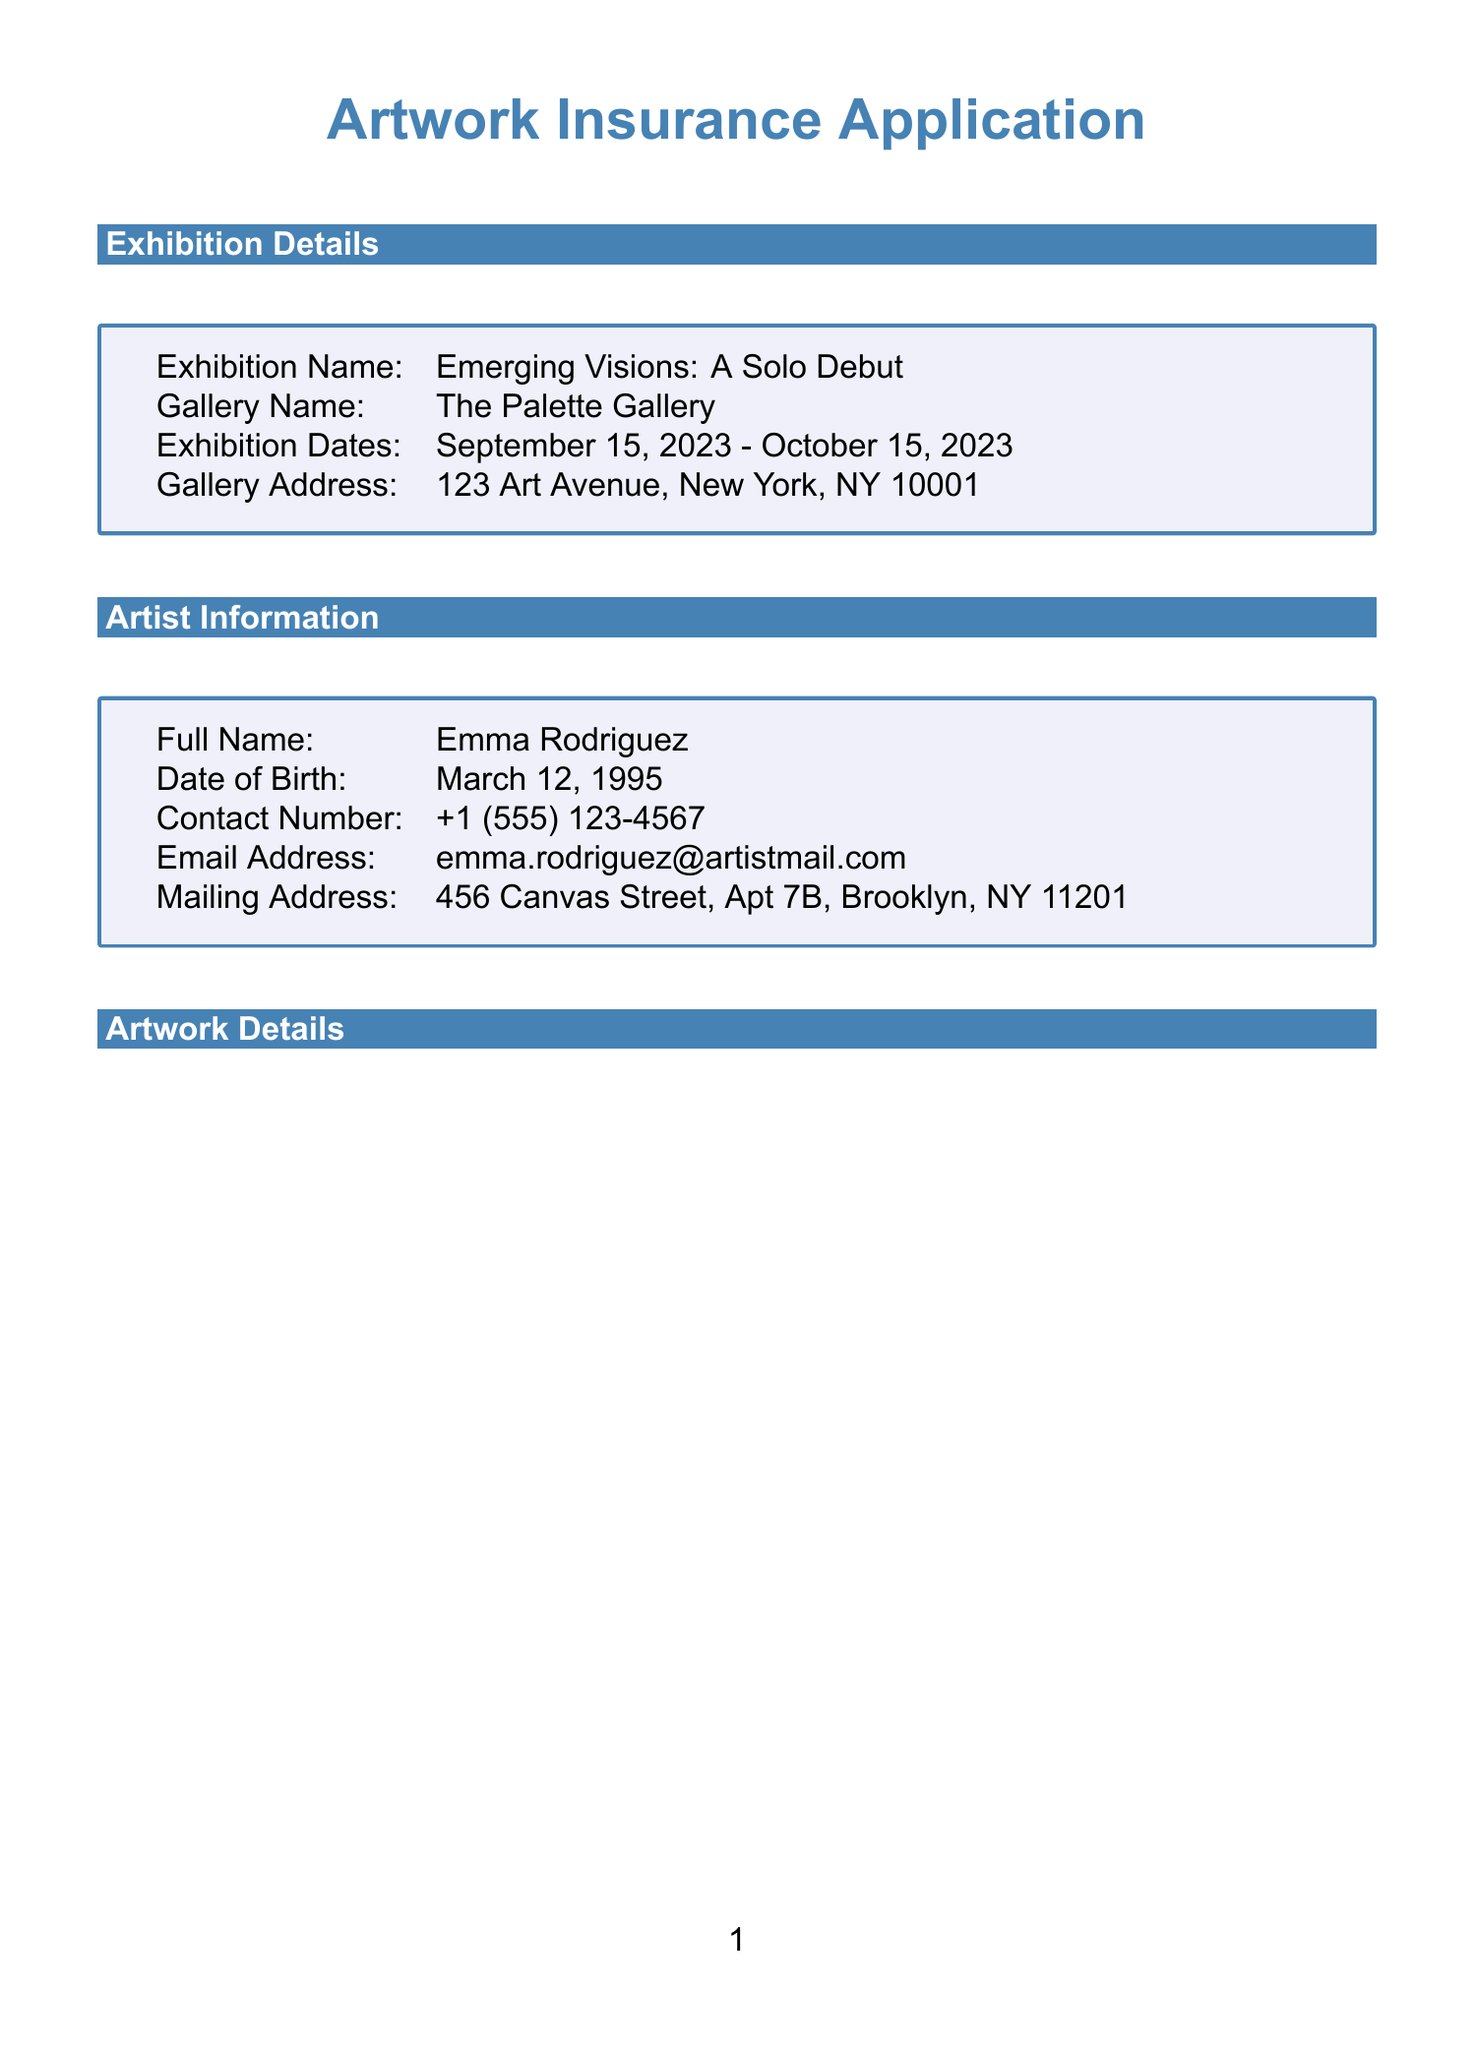what is the exhibition name? The exhibition name is clearly stated in the details section of the document.
Answer: Emerging Visions: A Solo Debut what is the estimated value of "Echoes of Solitude"? The estimated value of each artwork is listed in the artwork details section.
Answer: 4200 who is the artist? The full name of the artist is mentioned in the artist information section.
Answer: Emma Rodriguez when does the insurance coverage period end? The end date of the coverage period is specified in the insurance coverage section.
Answer: October 20, 2023 how many artworks are listed? The number of artworks can be counted from the artwork details section.
Answer: 3 what is the deductible amount for the insurance? The deductible amount is provided in the insurance coverage section.
Answer: 500 where is the gallery located? The gallery address is mentioned in the exhibition details section.
Answer: 123 Art Avenue, New York, NY 10001 what measures are taken during transit for security? The document lists security measures during transit in the security measures section.
Answer: GPS tracking, Temperature-controlled vehicle, Two-person team for loading and unloading what is the preferred payment method? The preferred payment method is listed under payment information in the document.
Answer: Credit card 